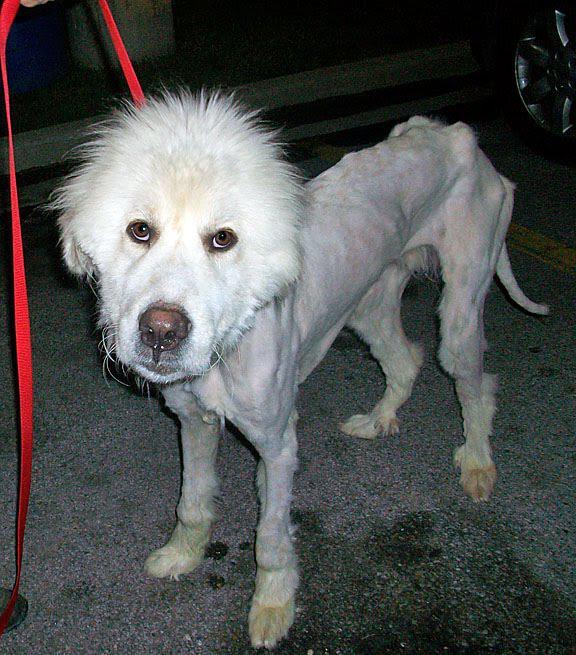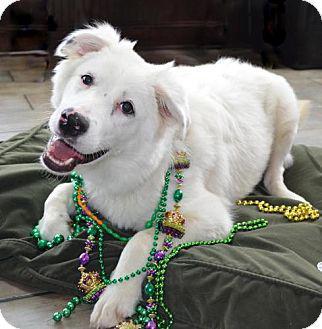The first image is the image on the left, the second image is the image on the right. Analyze the images presented: Is the assertion "A person is holding a dog in one of the images." valid? Answer yes or no. No. The first image is the image on the left, the second image is the image on the right. Analyze the images presented: Is the assertion "In one image a large white dog is being held by a man, while the second image shows a white dog sitting near a person." valid? Answer yes or no. No. 